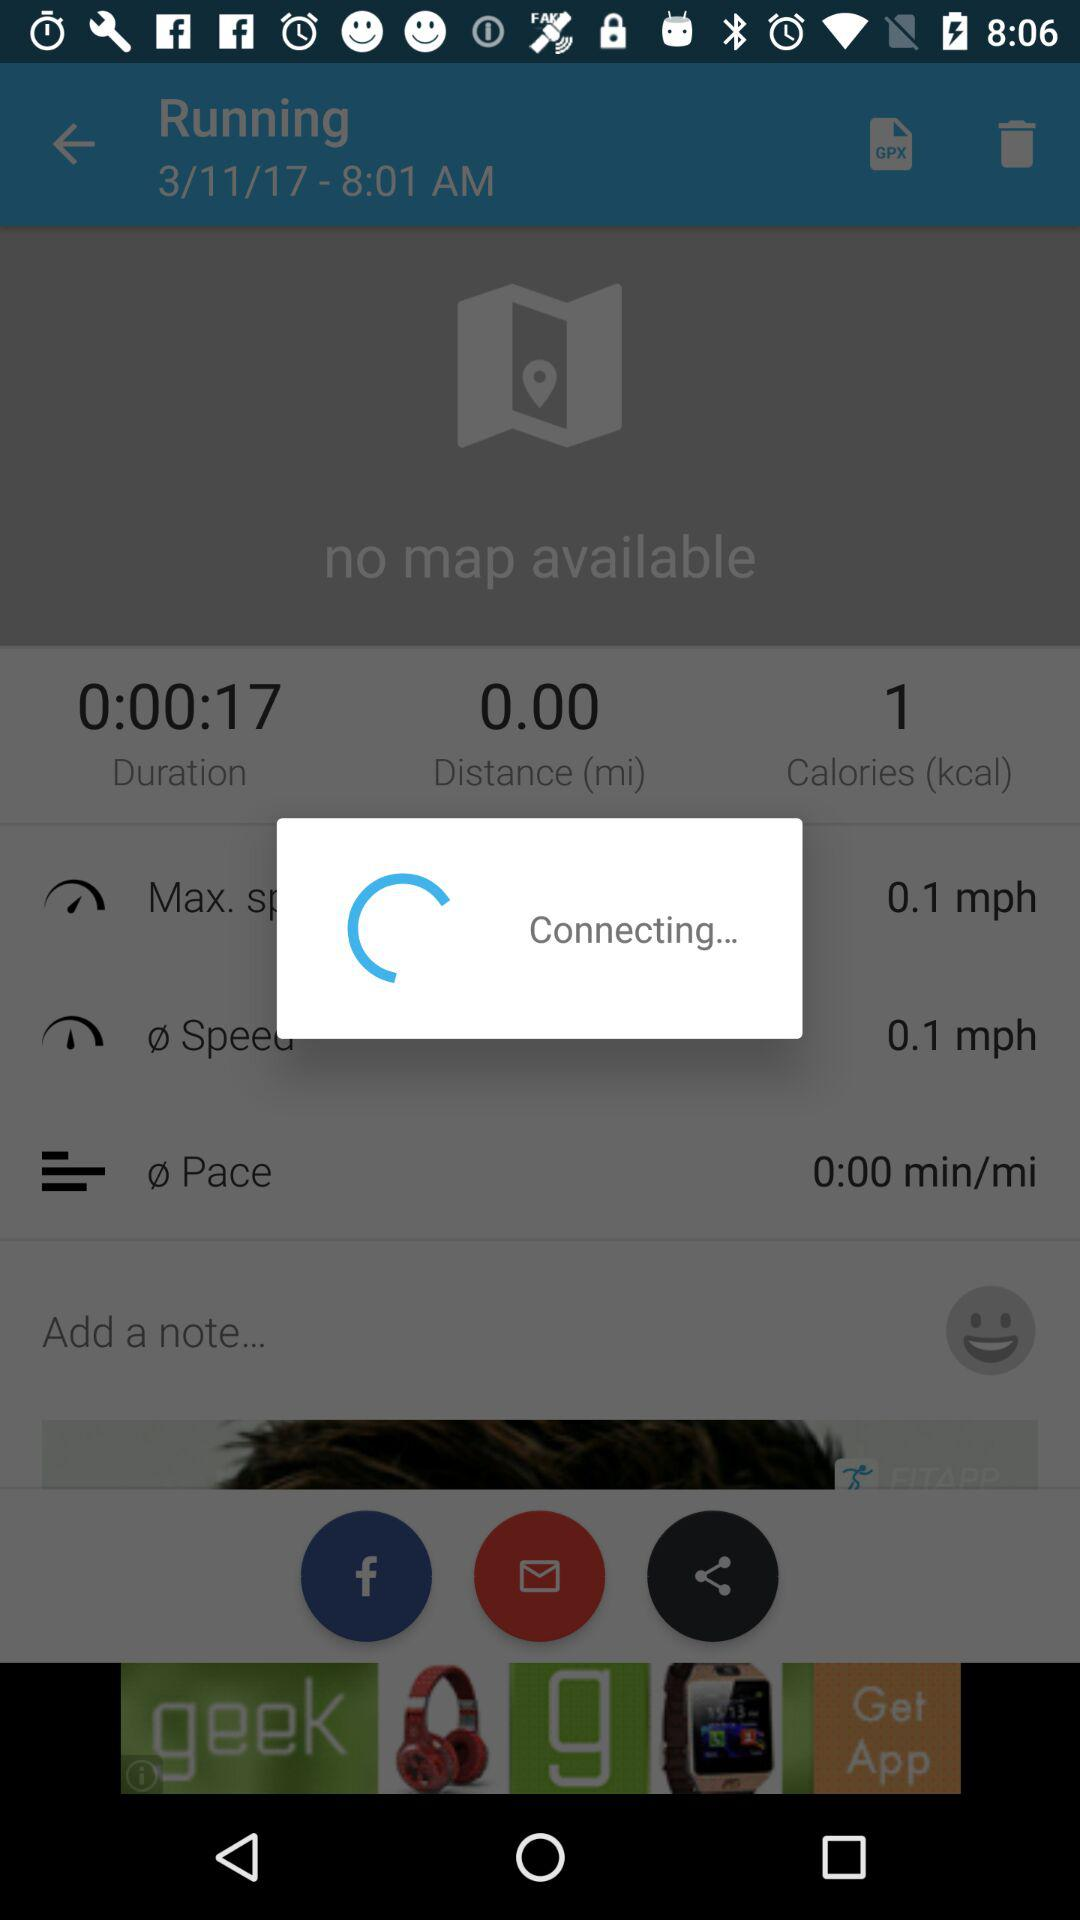What is the unit of calories? The unit of calories is kcal. 